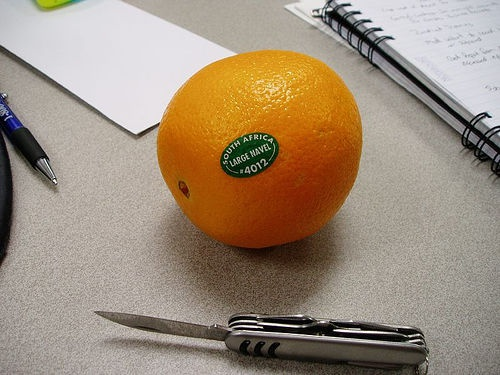Describe the objects in this image and their specific colors. I can see dining table in darkgray, gray, and black tones, orange in darkgray, brown, orange, and maroon tones, book in darkgray, lightgray, black, and gray tones, and knife in darkgray, black, and gray tones in this image. 